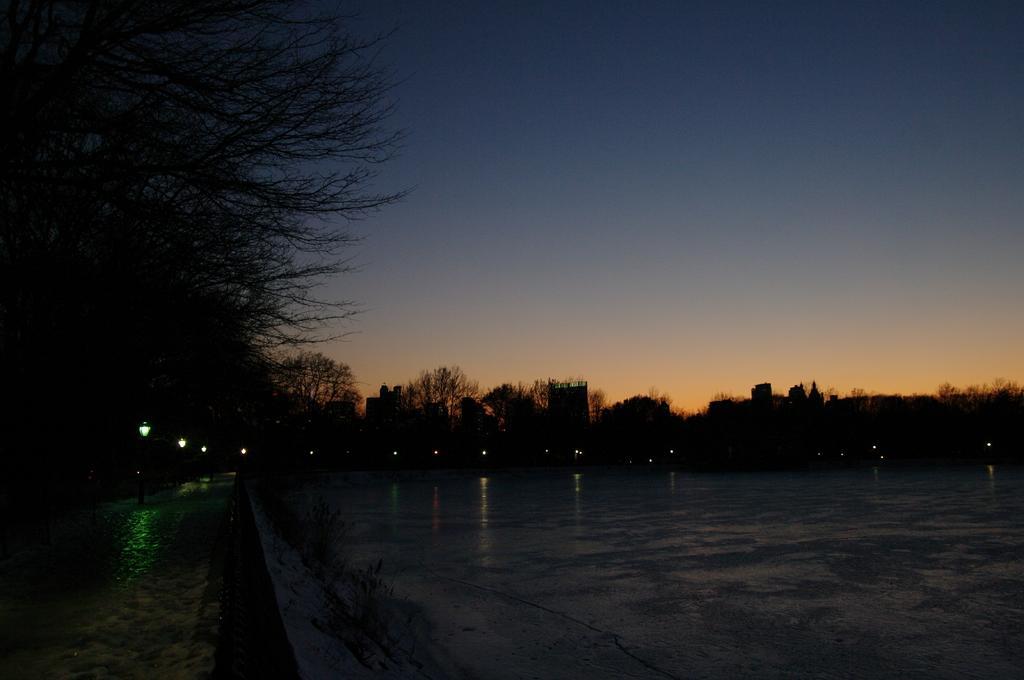Please provide a concise description of this image. This is a dark image, at the left side there are some trees, at the top there is a sky. 